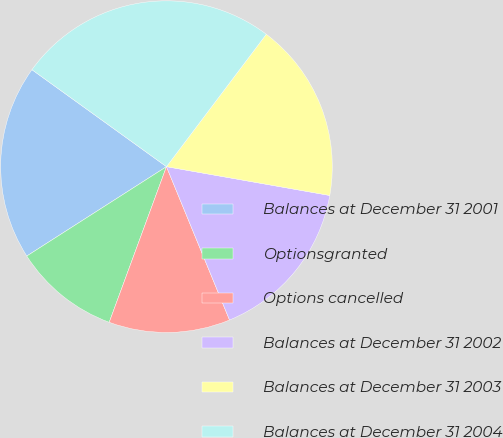<chart> <loc_0><loc_0><loc_500><loc_500><pie_chart><fcel>Balances at December 31 2001<fcel>Optionsgranted<fcel>Options cancelled<fcel>Balances at December 31 2002<fcel>Balances at December 31 2003<fcel>Balances at December 31 2004<nl><fcel>19.0%<fcel>10.33%<fcel>11.82%<fcel>16.01%<fcel>17.5%<fcel>25.34%<nl></chart> 